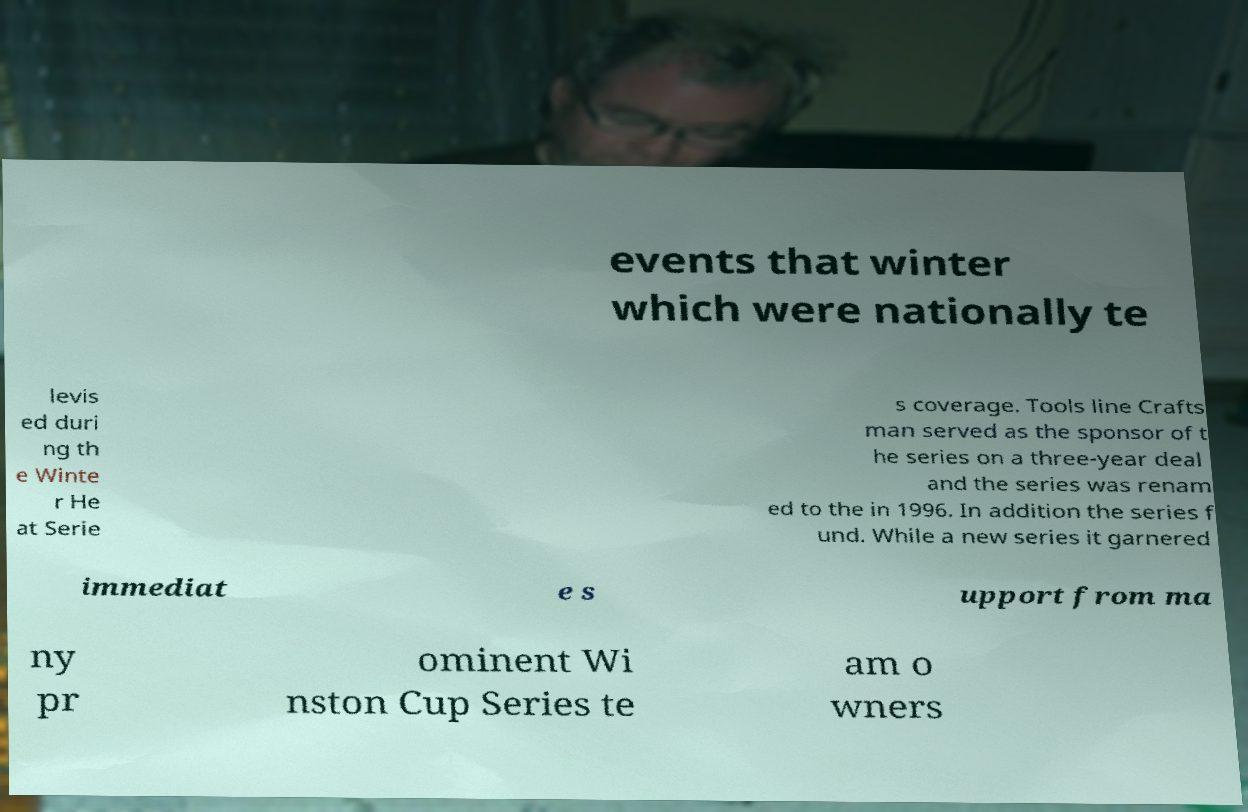What messages or text are displayed in this image? I need them in a readable, typed format. events that winter which were nationally te levis ed duri ng th e Winte r He at Serie s coverage. Tools line Crafts man served as the sponsor of t he series on a three-year deal and the series was renam ed to the in 1996. In addition the series f und. While a new series it garnered immediat e s upport from ma ny pr ominent Wi nston Cup Series te am o wners 